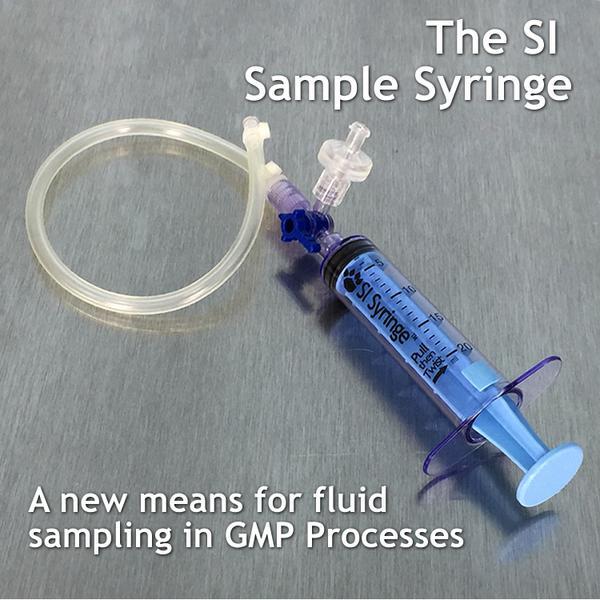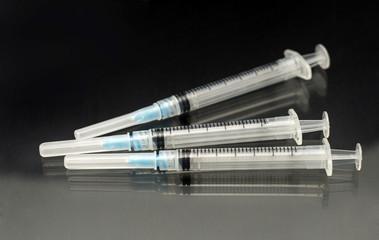The first image is the image on the left, the second image is the image on the right. Analyze the images presented: Is the assertion "There are four unbagged syringes, one in one image and three in the other." valid? Answer yes or no. Yes. The first image is the image on the left, the second image is the image on the right. Analyze the images presented: Is the assertion "There are two more syringes on the right side" valid? Answer yes or no. Yes. 